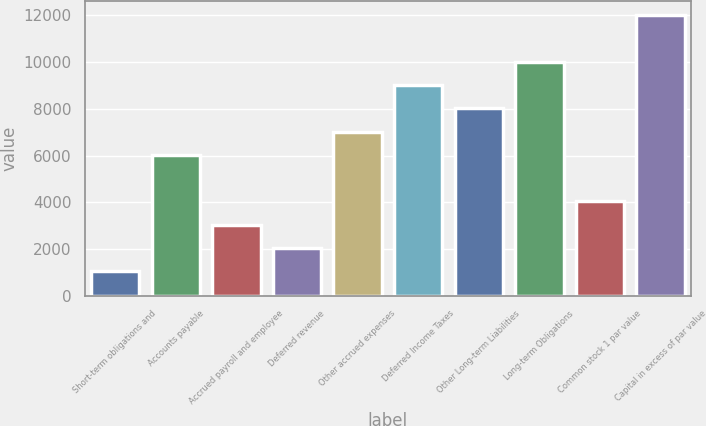Convert chart to OTSL. <chart><loc_0><loc_0><loc_500><loc_500><bar_chart><fcel>Short-term obligations and<fcel>Accounts payable<fcel>Accrued payroll and employee<fcel>Deferred revenue<fcel>Other accrued expenses<fcel>Deferred Income Taxes<fcel>Other Long-term Liabilities<fcel>Long-term Obligations<fcel>Common stock 1 par value<fcel>Capital in excess of par value<nl><fcel>1041.21<fcel>6029.26<fcel>3036.43<fcel>2038.82<fcel>7026.87<fcel>9022.09<fcel>8024.48<fcel>10019.7<fcel>4034.04<fcel>12014.9<nl></chart> 